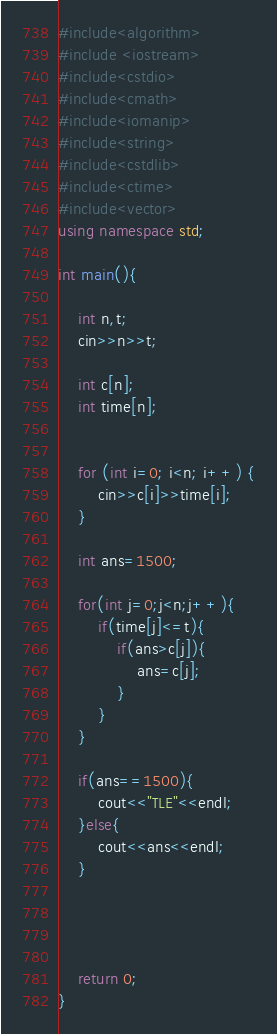Convert code to text. <code><loc_0><loc_0><loc_500><loc_500><_C++_>#include<algorithm>
#include <iostream>
#include<cstdio>
#include<cmath>
#include<iomanip>
#include<string>
#include<cstdlib>
#include<ctime>
#include<vector>
using namespace std;

int main(){
 
    int n,t;
    cin>>n>>t;
    
    int c[n];
    int time[n];
    
   
    for (int i=0; i<n; i++) {
        cin>>c[i]>>time[i];
    }
    
    int ans=1500;
    
    for(int j=0;j<n;j++){
        if(time[j]<=t){
            if(ans>c[j]){
                ans=c[j];
            }
        }
    }
    
    if(ans==1500){
        cout<<"TLE"<<endl;
    }else{
        cout<<ans<<endl;
    }
    
    
    
    
    return 0;
}
</code> 